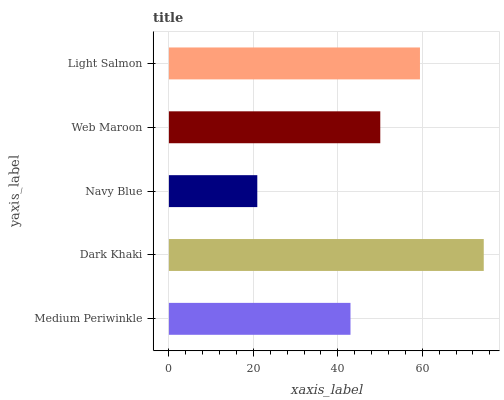Is Navy Blue the minimum?
Answer yes or no. Yes. Is Dark Khaki the maximum?
Answer yes or no. Yes. Is Dark Khaki the minimum?
Answer yes or no. No. Is Navy Blue the maximum?
Answer yes or no. No. Is Dark Khaki greater than Navy Blue?
Answer yes or no. Yes. Is Navy Blue less than Dark Khaki?
Answer yes or no. Yes. Is Navy Blue greater than Dark Khaki?
Answer yes or no. No. Is Dark Khaki less than Navy Blue?
Answer yes or no. No. Is Web Maroon the high median?
Answer yes or no. Yes. Is Web Maroon the low median?
Answer yes or no. Yes. Is Medium Periwinkle the high median?
Answer yes or no. No. Is Light Salmon the low median?
Answer yes or no. No. 